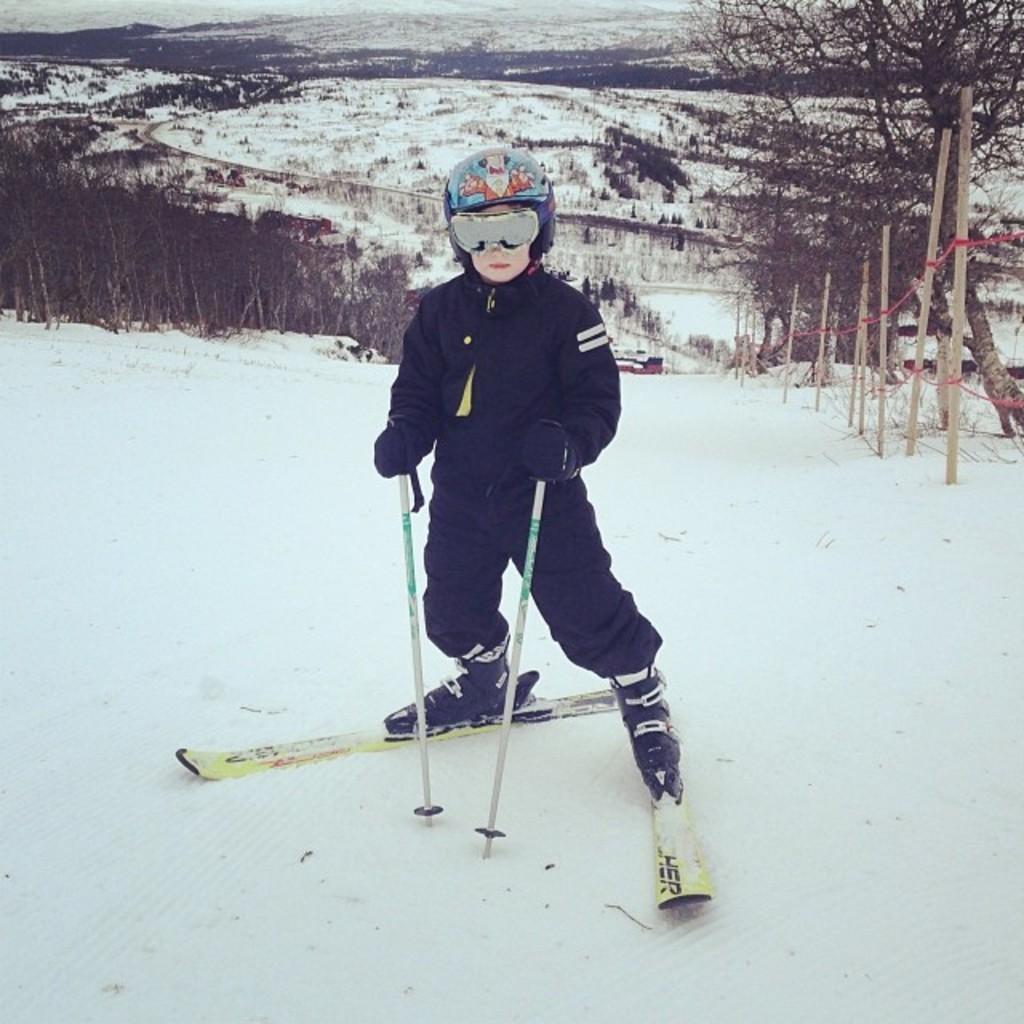Please provide a concise description of this image. This picture shows a person skiing on the snow and we can see some trees on the side 